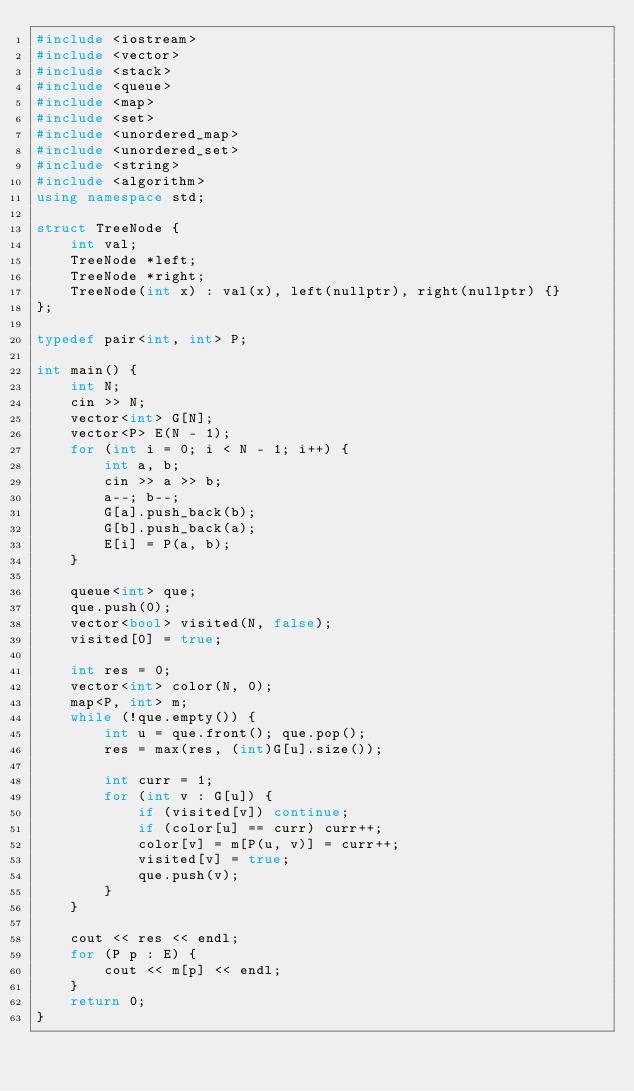Convert code to text. <code><loc_0><loc_0><loc_500><loc_500><_C++_>#include <iostream>
#include <vector>
#include <stack>
#include <queue>
#include <map>
#include <set>
#include <unordered_map>
#include <unordered_set>
#include <string>
#include <algorithm>
using namespace std;

struct TreeNode {
    int val;
    TreeNode *left;
    TreeNode *right;
    TreeNode(int x) : val(x), left(nullptr), right(nullptr) {}
};

typedef pair<int, int> P;

int main() {
    int N;
    cin >> N;
    vector<int> G[N];
    vector<P> E(N - 1);
    for (int i = 0; i < N - 1; i++) {
        int a, b;
        cin >> a >> b;
        a--; b--;
        G[a].push_back(b);
        G[b].push_back(a);
        E[i] = P(a, b);
    }

    queue<int> que;
    que.push(0);
    vector<bool> visited(N, false);
    visited[0] = true;

    int res = 0;
    vector<int> color(N, 0);
    map<P, int> m;
    while (!que.empty()) {
        int u = que.front(); que.pop();
        res = max(res, (int)G[u].size());

        int curr = 1;
        for (int v : G[u]) {
            if (visited[v]) continue;
            if (color[u] == curr) curr++;
            color[v] = m[P(u, v)] = curr++;
            visited[v] = true;
            que.push(v);
        }
    }

    cout << res << endl;
    for (P p : E) {
        cout << m[p] << endl;
    }
    return 0;
}
</code> 